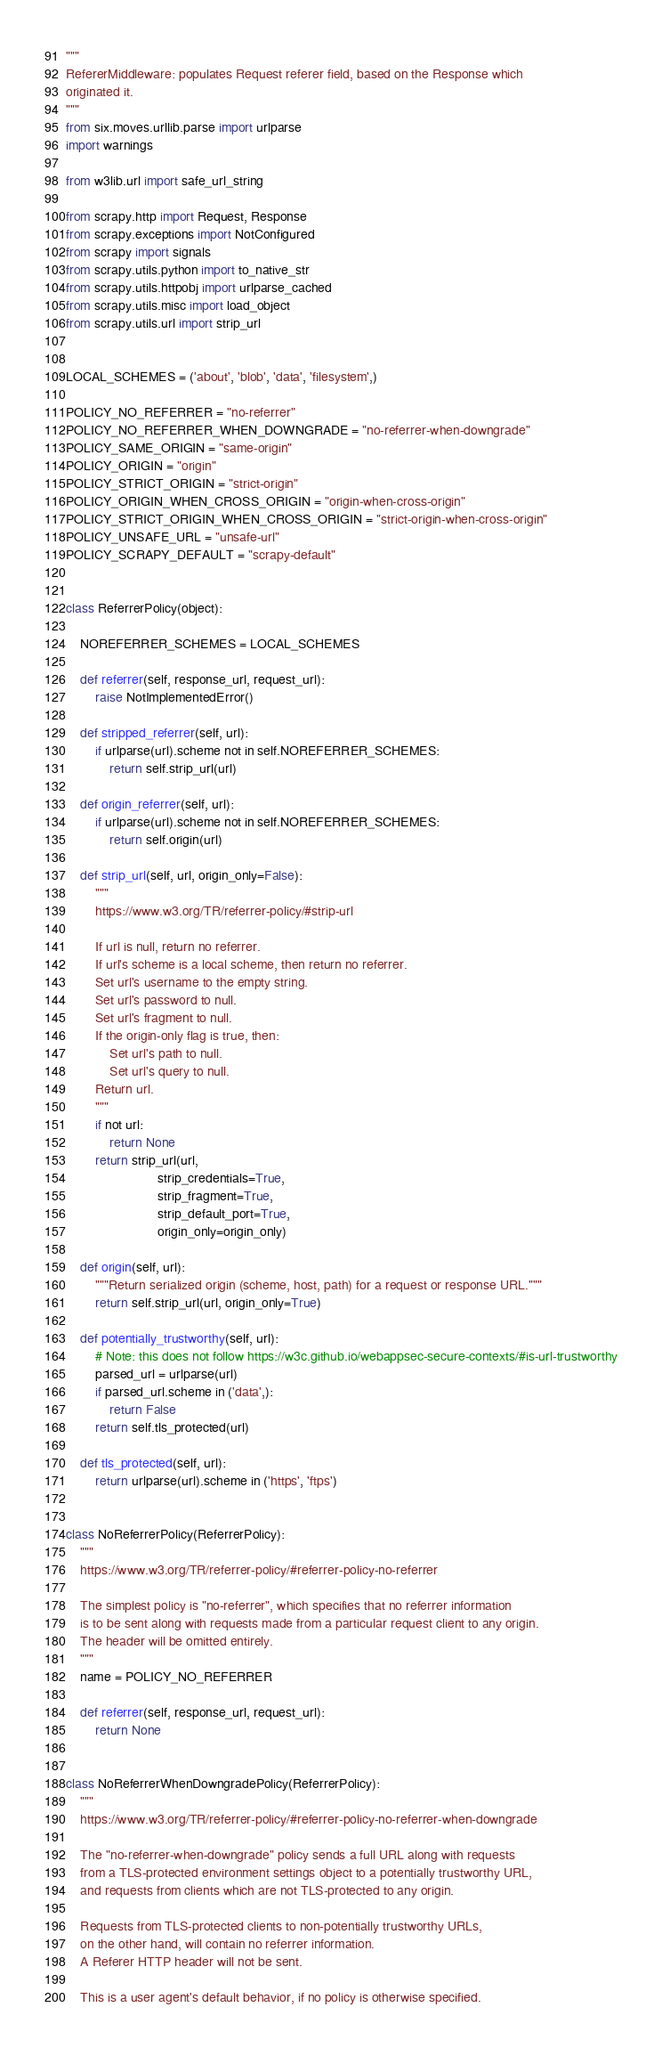Convert code to text. <code><loc_0><loc_0><loc_500><loc_500><_Python_>"""
RefererMiddleware: populates Request referer field, based on the Response which
originated it.
"""
from six.moves.urllib.parse import urlparse
import warnings

from w3lib.url import safe_url_string

from scrapy.http import Request, Response
from scrapy.exceptions import NotConfigured
from scrapy import signals
from scrapy.utils.python import to_native_str
from scrapy.utils.httpobj import urlparse_cached
from scrapy.utils.misc import load_object
from scrapy.utils.url import strip_url


LOCAL_SCHEMES = ('about', 'blob', 'data', 'filesystem',)

POLICY_NO_REFERRER = "no-referrer"
POLICY_NO_REFERRER_WHEN_DOWNGRADE = "no-referrer-when-downgrade"
POLICY_SAME_ORIGIN = "same-origin"
POLICY_ORIGIN = "origin"
POLICY_STRICT_ORIGIN = "strict-origin"
POLICY_ORIGIN_WHEN_CROSS_ORIGIN = "origin-when-cross-origin"
POLICY_STRICT_ORIGIN_WHEN_CROSS_ORIGIN = "strict-origin-when-cross-origin"
POLICY_UNSAFE_URL = "unsafe-url"
POLICY_SCRAPY_DEFAULT = "scrapy-default"


class ReferrerPolicy(object):

    NOREFERRER_SCHEMES = LOCAL_SCHEMES

    def referrer(self, response_url, request_url):
        raise NotImplementedError()

    def stripped_referrer(self, url):
        if urlparse(url).scheme not in self.NOREFERRER_SCHEMES:
            return self.strip_url(url)

    def origin_referrer(self, url):
        if urlparse(url).scheme not in self.NOREFERRER_SCHEMES:
            return self.origin(url)

    def strip_url(self, url, origin_only=False):
        """
        https://www.w3.org/TR/referrer-policy/#strip-url

        If url is null, return no referrer.
        If url's scheme is a local scheme, then return no referrer.
        Set url's username to the empty string.
        Set url's password to null.
        Set url's fragment to null.
        If the origin-only flag is true, then:
            Set url's path to null.
            Set url's query to null.
        Return url.
        """
        if not url:
            return None
        return strip_url(url,
                         strip_credentials=True,
                         strip_fragment=True,
                         strip_default_port=True,
                         origin_only=origin_only)

    def origin(self, url):
        """Return serialized origin (scheme, host, path) for a request or response URL."""
        return self.strip_url(url, origin_only=True)

    def potentially_trustworthy(self, url):
        # Note: this does not follow https://w3c.github.io/webappsec-secure-contexts/#is-url-trustworthy
        parsed_url = urlparse(url)
        if parsed_url.scheme in ('data',):
            return False
        return self.tls_protected(url)

    def tls_protected(self, url):
        return urlparse(url).scheme in ('https', 'ftps')


class NoReferrerPolicy(ReferrerPolicy):
    """
    https://www.w3.org/TR/referrer-policy/#referrer-policy-no-referrer

    The simplest policy is "no-referrer", which specifies that no referrer information
    is to be sent along with requests made from a particular request client to any origin.
    The header will be omitted entirely.
    """
    name = POLICY_NO_REFERRER

    def referrer(self, response_url, request_url):
        return None


class NoReferrerWhenDowngradePolicy(ReferrerPolicy):
    """
    https://www.w3.org/TR/referrer-policy/#referrer-policy-no-referrer-when-downgrade

    The "no-referrer-when-downgrade" policy sends a full URL along with requests
    from a TLS-protected environment settings object to a potentially trustworthy URL,
    and requests from clients which are not TLS-protected to any origin.

    Requests from TLS-protected clients to non-potentially trustworthy URLs,
    on the other hand, will contain no referrer information.
    A Referer HTTP header will not be sent.

    This is a user agent's default behavior, if no policy is otherwise specified.</code> 